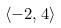<formula> <loc_0><loc_0><loc_500><loc_500>\langle - 2 , 4 \rangle</formula> 